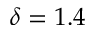<formula> <loc_0><loc_0><loc_500><loc_500>\delta = 1 . 4</formula> 